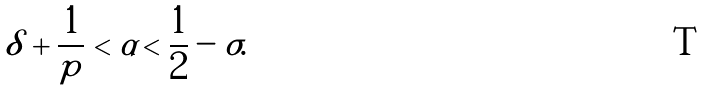Convert formula to latex. <formula><loc_0><loc_0><loc_500><loc_500>\delta + \frac { 1 } { p } < \alpha < \frac { 1 } { 2 } - \sigma .</formula> 